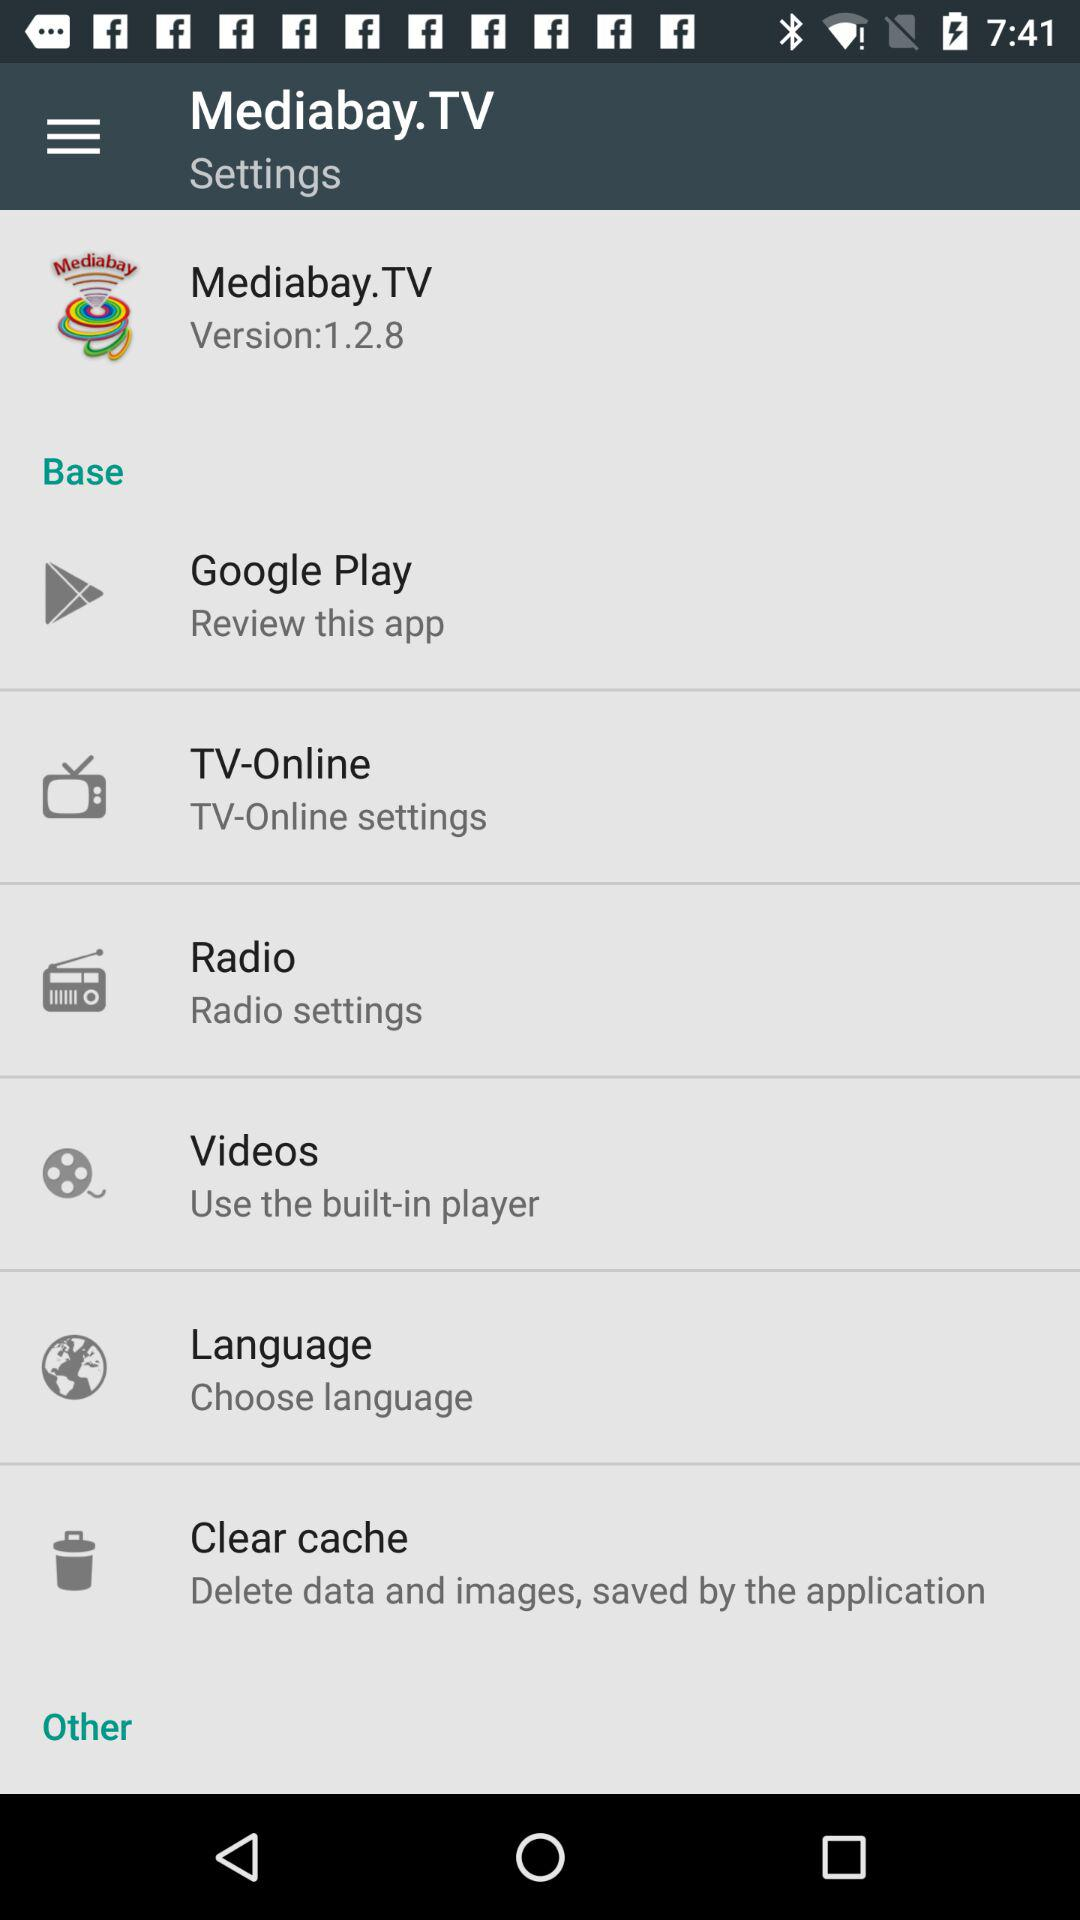What is the application name? The application name is "Mediabay.TV". 